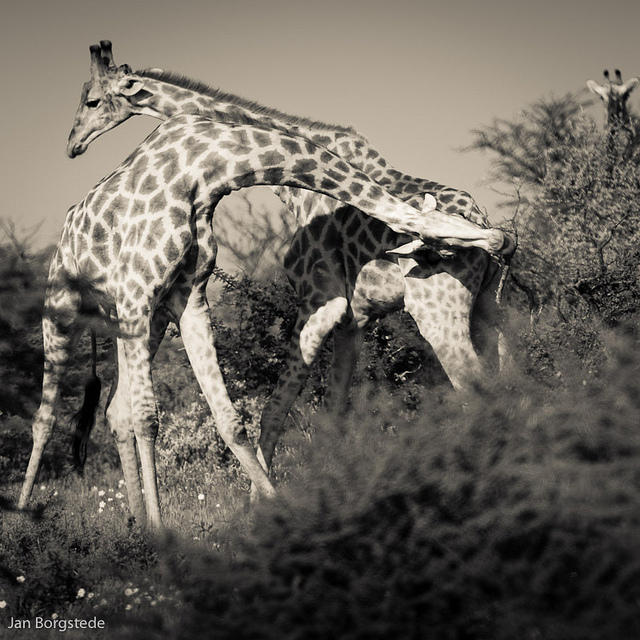Please transcribe the text information in this image. Jan Borgstede 